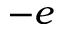Convert formula to latex. <formula><loc_0><loc_0><loc_500><loc_500>- e</formula> 